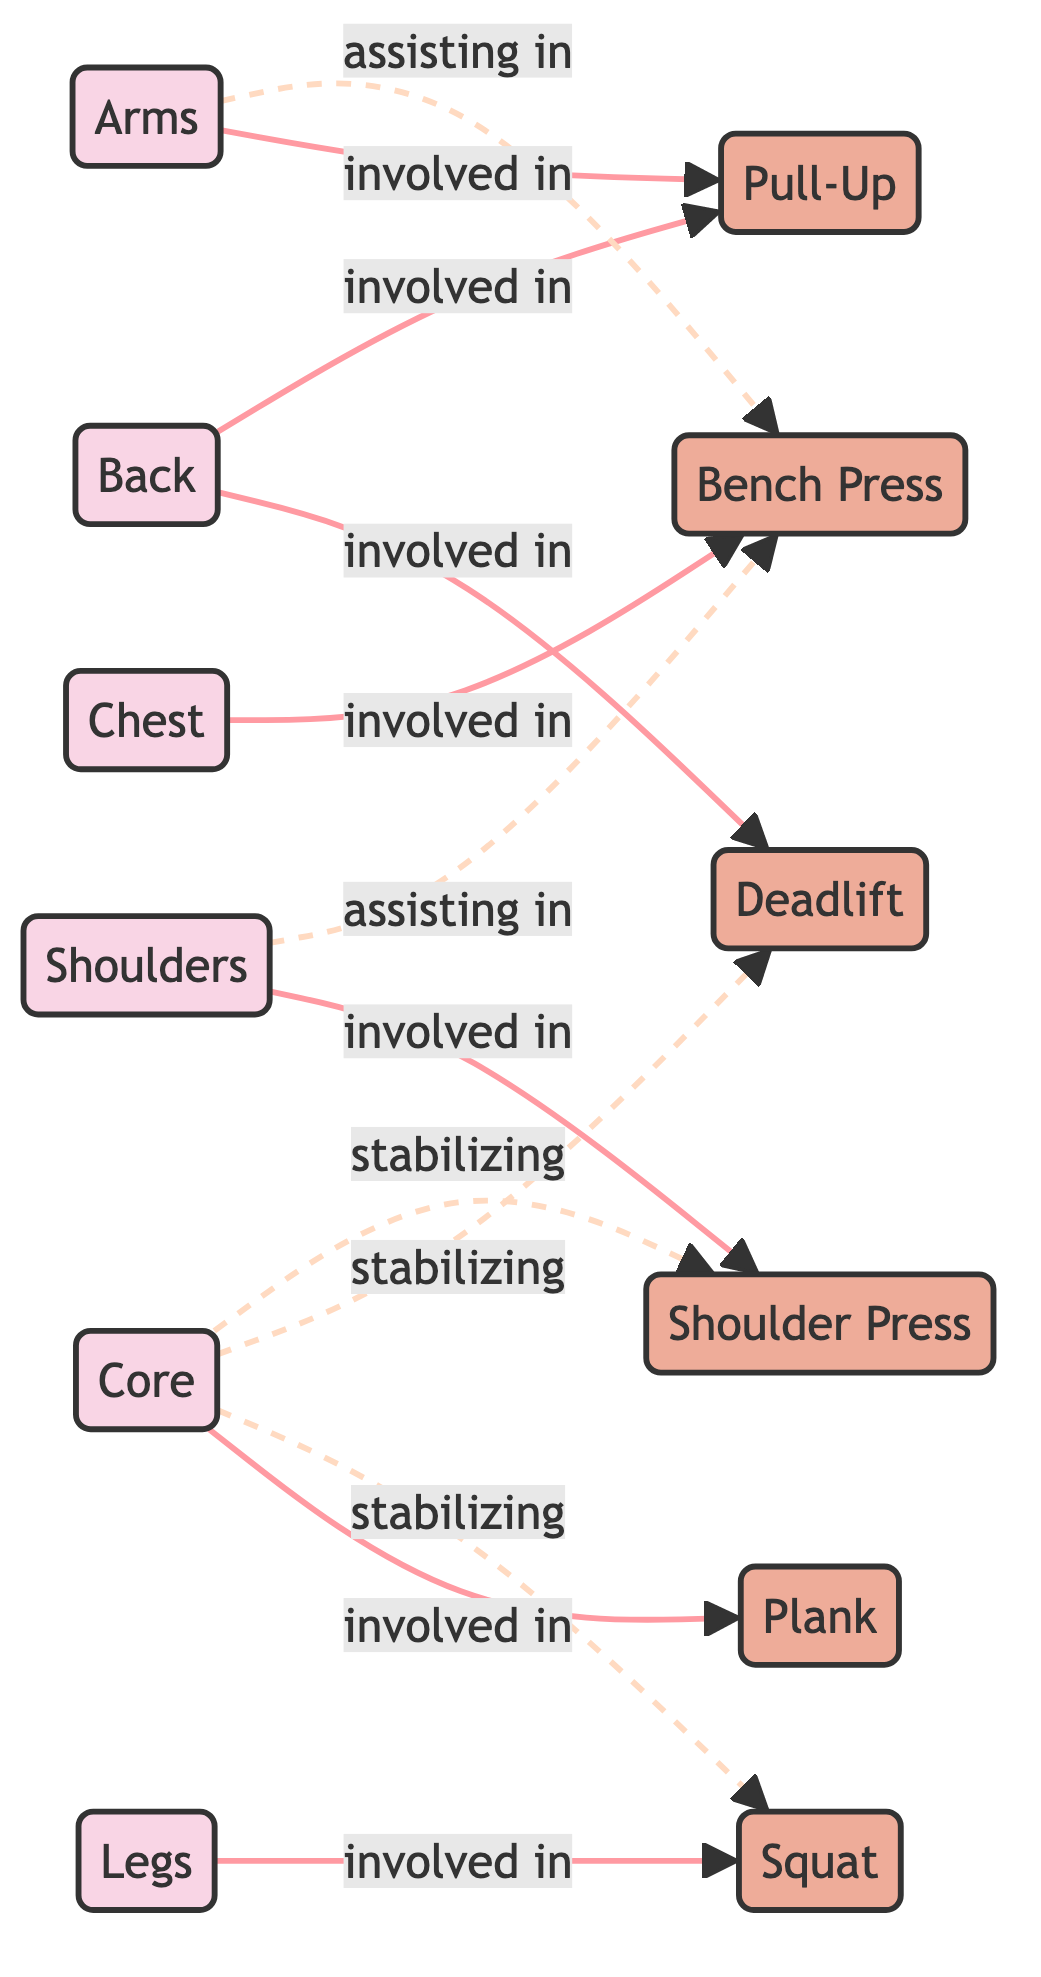What muscle group is involved in the Bench Press exercise? The diagram shows a direct connection (edge) from the "Chest" node to the "Bench Press" node with the relationship labeled as "involved in". Therefore, the muscle group involved in the Bench Press is the Chest.
Answer: Chest How many muscle groups are represented in the diagram? The diagram lists a total of six nodes categorized as muscle groups: Chest, Back, Legs, Arms, Shoulders, and Core. Therefore, the count of muscle groups is six.
Answer: 6 Which shoulder-related exercise is shown in the diagram? The diagram shows a direct connection (edge) from the "Shoulders" node to the "Shoulder Press" node with the relationship labeled as "involved in". Thus, the exercise related to the shoulders is the Shoulder Press.
Answer: Shoulder Press What is the relationship between the Legs muscle group and the Squat exercise? There is a direct edge in the diagram from the "Legs" muscle group to the "Squat" exercise, labeled "involved in", indicating they have a direct relationship.
Answer: involved in Which muscle group assists in the Bench Press? The diagram has indirect edges (dotted lines) from the "Arms" and "Shoulders" nodes to the "Bench Press" node, showing that both these muscle groups assist in this exercise. Thus, both the Arms and Shoulders assist in the Bench Press.
Answer: Arms and Shoulders How many exercises are shown in the diagram? The diagram contains a total of six distinct exercise nodes: Bench Press, Deadlift, Squat, Pull-Up, Shoulder Press, and Plank. Hence, the total number of exercises is six.
Answer: 6 What role does the Core muscle group play in the Squat exercise? According to the diagram, there is a dotted edge labeled "stabilizing" linking the "Core" muscle group to the "Squat" exercise, indicating that the Core helps to stabilize during this exercise.
Answer: stabilizing Which exercise is primarily associated with the Back muscle group? The direct edge between the "Back" muscle group and the "Deadlift" exercise, marked "involved in", indicates that the Deadlift is primarily associated with the Back muscle group.
Answer: Deadlift What is the relationship between the Core muscle group and the Shoulder Press exercise? The diagram shows an edge labeled "stabilizing" from the "Core" muscle group to the "Shoulder Press" exercise, suggesting that the Core plays a stabilizing role during this exercise.
Answer: stabilizing 